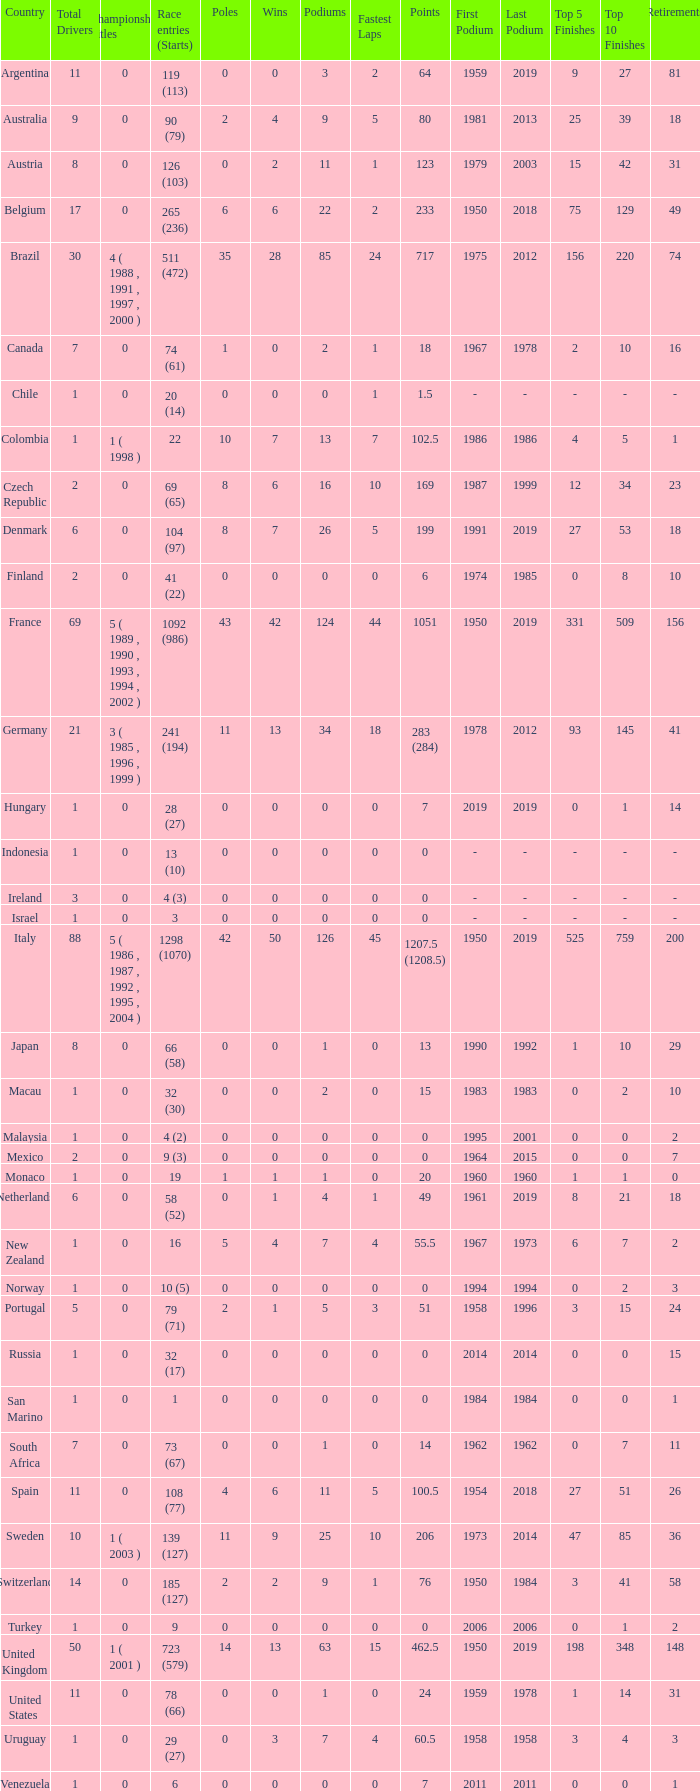How many titles for the nation with less than 3 fastest laps and 22 podiums? 0.0. 